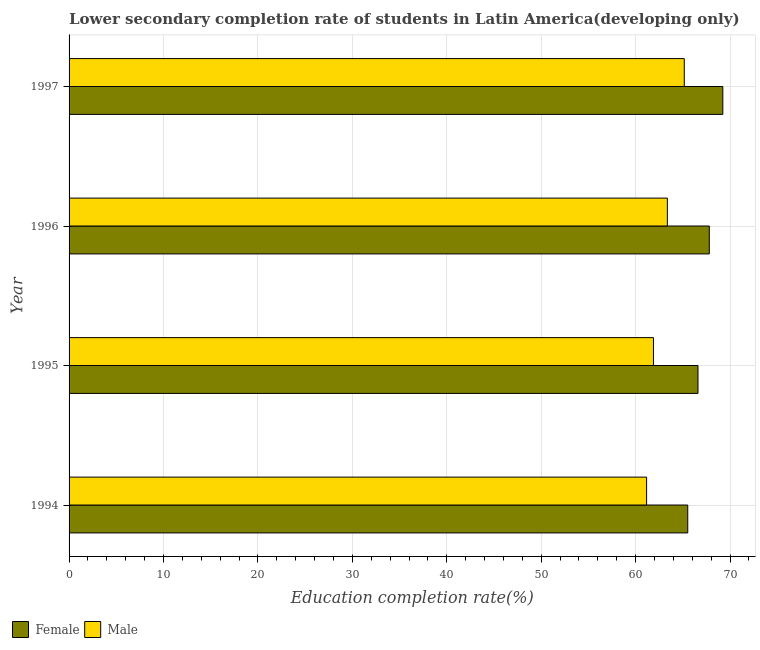How many different coloured bars are there?
Offer a terse response. 2. Are the number of bars on each tick of the Y-axis equal?
Ensure brevity in your answer.  Yes. How many bars are there on the 4th tick from the bottom?
Offer a very short reply. 2. What is the label of the 3rd group of bars from the top?
Your answer should be compact. 1995. In how many cases, is the number of bars for a given year not equal to the number of legend labels?
Your answer should be very brief. 0. What is the education completion rate of female students in 1994?
Provide a short and direct response. 65.52. Across all years, what is the maximum education completion rate of female students?
Ensure brevity in your answer.  69.23. Across all years, what is the minimum education completion rate of male students?
Provide a succinct answer. 61.16. In which year was the education completion rate of male students minimum?
Your answer should be very brief. 1994. What is the total education completion rate of female students in the graph?
Make the answer very short. 269.16. What is the difference between the education completion rate of male students in 1997 and the education completion rate of female students in 1995?
Provide a short and direct response. -1.46. What is the average education completion rate of female students per year?
Give a very brief answer. 67.29. In the year 1994, what is the difference between the education completion rate of male students and education completion rate of female students?
Your response must be concise. -4.36. In how many years, is the education completion rate of female students greater than 8 %?
Your answer should be very brief. 4. What is the ratio of the education completion rate of male students in 1996 to that in 1997?
Provide a short and direct response. 0.97. Is the education completion rate of male students in 1996 less than that in 1997?
Your answer should be very brief. Yes. What is the difference between the highest and the second highest education completion rate of male students?
Provide a succinct answer. 1.79. What is the difference between the highest and the lowest education completion rate of female students?
Ensure brevity in your answer.  3.71. What does the 1st bar from the top in 1996 represents?
Offer a very short reply. Male. How many bars are there?
Provide a succinct answer. 8. What is the difference between two consecutive major ticks on the X-axis?
Keep it short and to the point. 10. Are the values on the major ticks of X-axis written in scientific E-notation?
Ensure brevity in your answer.  No. Does the graph contain grids?
Give a very brief answer. Yes. Where does the legend appear in the graph?
Your answer should be very brief. Bottom left. How many legend labels are there?
Provide a succinct answer. 2. What is the title of the graph?
Provide a succinct answer. Lower secondary completion rate of students in Latin America(developing only). Does "Fraud firms" appear as one of the legend labels in the graph?
Your answer should be compact. No. What is the label or title of the X-axis?
Provide a succinct answer. Education completion rate(%). What is the label or title of the Y-axis?
Keep it short and to the point. Year. What is the Education completion rate(%) in Female in 1994?
Your answer should be compact. 65.52. What is the Education completion rate(%) of Male in 1994?
Offer a very short reply. 61.16. What is the Education completion rate(%) of Female in 1995?
Make the answer very short. 66.61. What is the Education completion rate(%) in Male in 1995?
Make the answer very short. 61.89. What is the Education completion rate(%) of Female in 1996?
Your answer should be compact. 67.8. What is the Education completion rate(%) in Male in 1996?
Give a very brief answer. 63.36. What is the Education completion rate(%) of Female in 1997?
Offer a terse response. 69.23. What is the Education completion rate(%) of Male in 1997?
Ensure brevity in your answer.  65.15. Across all years, what is the maximum Education completion rate(%) of Female?
Give a very brief answer. 69.23. Across all years, what is the maximum Education completion rate(%) of Male?
Your answer should be very brief. 65.15. Across all years, what is the minimum Education completion rate(%) of Female?
Make the answer very short. 65.52. Across all years, what is the minimum Education completion rate(%) in Male?
Make the answer very short. 61.16. What is the total Education completion rate(%) of Female in the graph?
Your response must be concise. 269.16. What is the total Education completion rate(%) of Male in the graph?
Your answer should be very brief. 251.56. What is the difference between the Education completion rate(%) of Female in 1994 and that in 1995?
Your answer should be compact. -1.09. What is the difference between the Education completion rate(%) in Male in 1994 and that in 1995?
Provide a short and direct response. -0.73. What is the difference between the Education completion rate(%) of Female in 1994 and that in 1996?
Your answer should be very brief. -2.28. What is the difference between the Education completion rate(%) in Male in 1994 and that in 1996?
Your answer should be very brief. -2.2. What is the difference between the Education completion rate(%) of Female in 1994 and that in 1997?
Keep it short and to the point. -3.71. What is the difference between the Education completion rate(%) in Male in 1994 and that in 1997?
Keep it short and to the point. -3.99. What is the difference between the Education completion rate(%) of Female in 1995 and that in 1996?
Ensure brevity in your answer.  -1.2. What is the difference between the Education completion rate(%) in Male in 1995 and that in 1996?
Offer a very short reply. -1.47. What is the difference between the Education completion rate(%) of Female in 1995 and that in 1997?
Offer a very short reply. -2.63. What is the difference between the Education completion rate(%) of Male in 1995 and that in 1997?
Offer a very short reply. -3.26. What is the difference between the Education completion rate(%) of Female in 1996 and that in 1997?
Your answer should be compact. -1.43. What is the difference between the Education completion rate(%) in Male in 1996 and that in 1997?
Provide a short and direct response. -1.79. What is the difference between the Education completion rate(%) in Female in 1994 and the Education completion rate(%) in Male in 1995?
Give a very brief answer. 3.63. What is the difference between the Education completion rate(%) in Female in 1994 and the Education completion rate(%) in Male in 1996?
Your response must be concise. 2.16. What is the difference between the Education completion rate(%) of Female in 1994 and the Education completion rate(%) of Male in 1997?
Offer a very short reply. 0.37. What is the difference between the Education completion rate(%) in Female in 1995 and the Education completion rate(%) in Male in 1996?
Keep it short and to the point. 3.24. What is the difference between the Education completion rate(%) in Female in 1995 and the Education completion rate(%) in Male in 1997?
Your response must be concise. 1.46. What is the difference between the Education completion rate(%) in Female in 1996 and the Education completion rate(%) in Male in 1997?
Give a very brief answer. 2.65. What is the average Education completion rate(%) of Female per year?
Ensure brevity in your answer.  67.29. What is the average Education completion rate(%) in Male per year?
Your answer should be very brief. 62.89. In the year 1994, what is the difference between the Education completion rate(%) of Female and Education completion rate(%) of Male?
Give a very brief answer. 4.36. In the year 1995, what is the difference between the Education completion rate(%) of Female and Education completion rate(%) of Male?
Your response must be concise. 4.72. In the year 1996, what is the difference between the Education completion rate(%) of Female and Education completion rate(%) of Male?
Offer a very short reply. 4.44. In the year 1997, what is the difference between the Education completion rate(%) of Female and Education completion rate(%) of Male?
Make the answer very short. 4.08. What is the ratio of the Education completion rate(%) in Female in 1994 to that in 1995?
Offer a very short reply. 0.98. What is the ratio of the Education completion rate(%) in Male in 1994 to that in 1995?
Provide a short and direct response. 0.99. What is the ratio of the Education completion rate(%) of Female in 1994 to that in 1996?
Your response must be concise. 0.97. What is the ratio of the Education completion rate(%) of Male in 1994 to that in 1996?
Ensure brevity in your answer.  0.97. What is the ratio of the Education completion rate(%) in Female in 1994 to that in 1997?
Offer a terse response. 0.95. What is the ratio of the Education completion rate(%) of Male in 1994 to that in 1997?
Make the answer very short. 0.94. What is the ratio of the Education completion rate(%) of Female in 1995 to that in 1996?
Offer a terse response. 0.98. What is the ratio of the Education completion rate(%) in Male in 1995 to that in 1996?
Make the answer very short. 0.98. What is the ratio of the Education completion rate(%) in Female in 1995 to that in 1997?
Offer a very short reply. 0.96. What is the ratio of the Education completion rate(%) of Male in 1995 to that in 1997?
Your response must be concise. 0.95. What is the ratio of the Education completion rate(%) of Female in 1996 to that in 1997?
Provide a succinct answer. 0.98. What is the ratio of the Education completion rate(%) in Male in 1996 to that in 1997?
Your response must be concise. 0.97. What is the difference between the highest and the second highest Education completion rate(%) in Female?
Provide a short and direct response. 1.43. What is the difference between the highest and the second highest Education completion rate(%) of Male?
Provide a short and direct response. 1.79. What is the difference between the highest and the lowest Education completion rate(%) of Female?
Your response must be concise. 3.71. What is the difference between the highest and the lowest Education completion rate(%) of Male?
Provide a short and direct response. 3.99. 